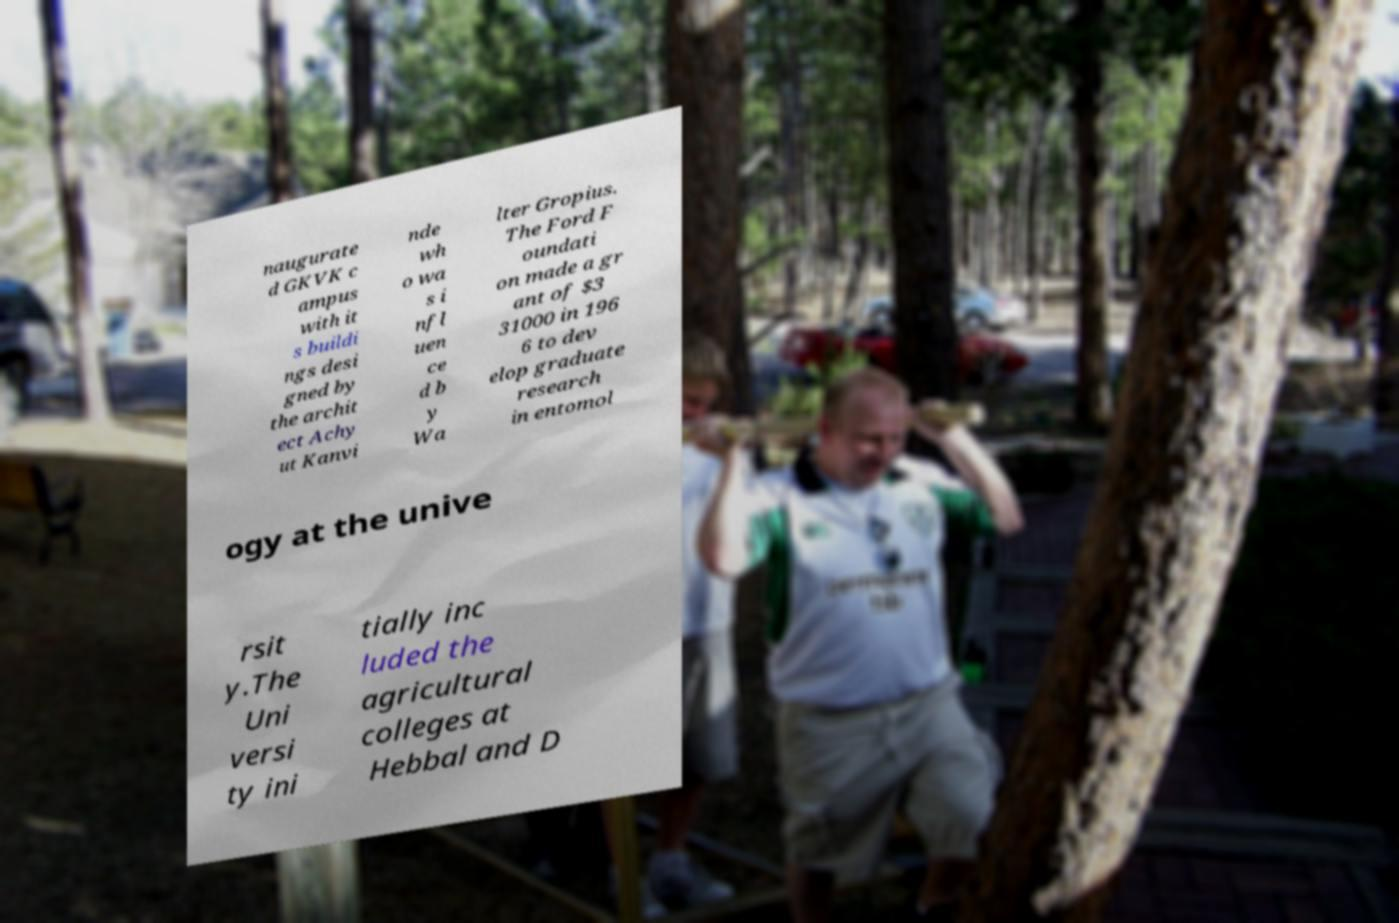I need the written content from this picture converted into text. Can you do that? naugurate d GKVK c ampus with it s buildi ngs desi gned by the archit ect Achy ut Kanvi nde wh o wa s i nfl uen ce d b y Wa lter Gropius. The Ford F oundati on made a gr ant of $3 31000 in 196 6 to dev elop graduate research in entomol ogy at the unive rsit y.The Uni versi ty ini tially inc luded the agricultural colleges at Hebbal and D 